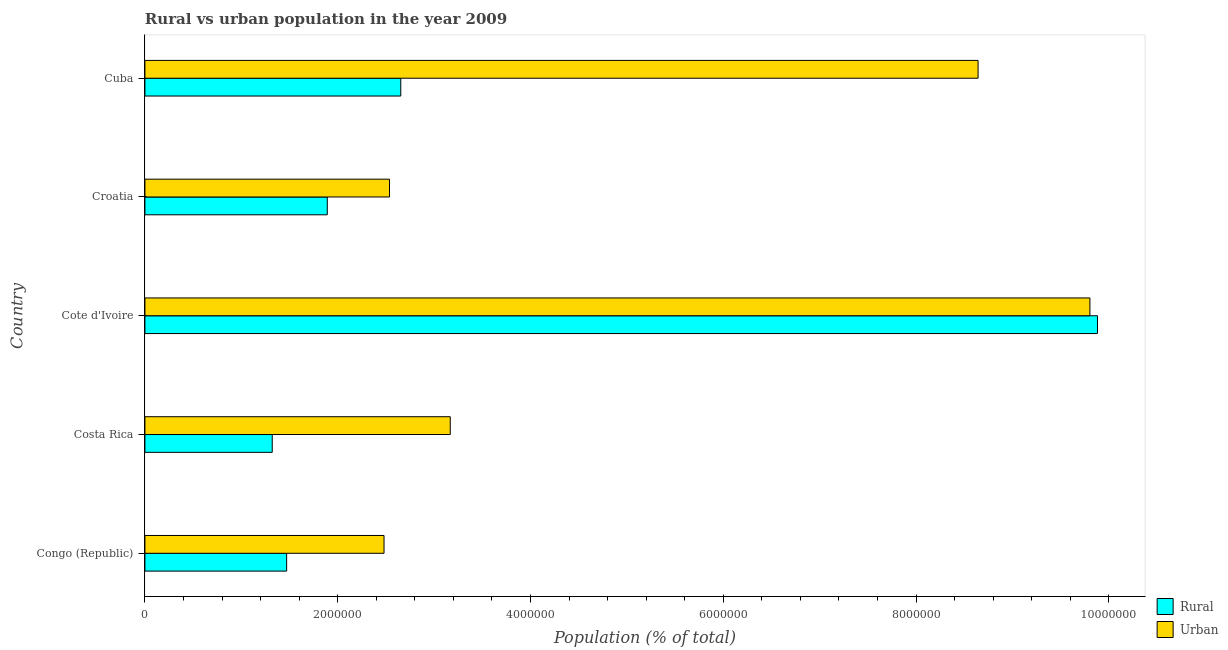How many groups of bars are there?
Offer a very short reply. 5. Are the number of bars per tick equal to the number of legend labels?
Keep it short and to the point. Yes. Are the number of bars on each tick of the Y-axis equal?
Provide a succinct answer. Yes. How many bars are there on the 5th tick from the bottom?
Keep it short and to the point. 2. What is the label of the 4th group of bars from the top?
Offer a terse response. Costa Rica. What is the rural population density in Cote d'Ivoire?
Provide a succinct answer. 9.88e+06. Across all countries, what is the maximum urban population density?
Offer a very short reply. 9.80e+06. Across all countries, what is the minimum rural population density?
Offer a terse response. 1.32e+06. In which country was the rural population density maximum?
Give a very brief answer. Cote d'Ivoire. In which country was the urban population density minimum?
Give a very brief answer. Congo (Republic). What is the total urban population density in the graph?
Your answer should be compact. 2.66e+07. What is the difference between the urban population density in Congo (Republic) and that in Cote d'Ivoire?
Your answer should be compact. -7.32e+06. What is the difference between the urban population density in Congo (Republic) and the rural population density in Cuba?
Offer a terse response. -1.74e+05. What is the average urban population density per country?
Provide a short and direct response. 5.33e+06. What is the difference between the rural population density and urban population density in Cote d'Ivoire?
Make the answer very short. 7.87e+04. In how many countries, is the urban population density greater than 1200000 %?
Offer a terse response. 5. What is the ratio of the urban population density in Costa Rica to that in Croatia?
Offer a very short reply. 1.25. Is the urban population density in Congo (Republic) less than that in Croatia?
Keep it short and to the point. Yes. What is the difference between the highest and the second highest urban population density?
Ensure brevity in your answer.  1.16e+06. What is the difference between the highest and the lowest urban population density?
Provide a succinct answer. 7.32e+06. What does the 2nd bar from the top in Cuba represents?
Your answer should be very brief. Rural. What does the 1st bar from the bottom in Cote d'Ivoire represents?
Provide a short and direct response. Rural. Are all the bars in the graph horizontal?
Offer a terse response. Yes. What is the difference between two consecutive major ticks on the X-axis?
Provide a short and direct response. 2.00e+06. Does the graph contain any zero values?
Provide a succinct answer. No. Does the graph contain grids?
Keep it short and to the point. No. Where does the legend appear in the graph?
Provide a short and direct response. Bottom right. How many legend labels are there?
Give a very brief answer. 2. How are the legend labels stacked?
Ensure brevity in your answer.  Vertical. What is the title of the graph?
Ensure brevity in your answer.  Rural vs urban population in the year 2009. What is the label or title of the X-axis?
Ensure brevity in your answer.  Population (% of total). What is the label or title of the Y-axis?
Your response must be concise. Country. What is the Population (% of total) of Rural in Congo (Republic)?
Give a very brief answer. 1.47e+06. What is the Population (% of total) in Urban in Congo (Republic)?
Your answer should be very brief. 2.48e+06. What is the Population (% of total) of Rural in Costa Rica?
Provide a succinct answer. 1.32e+06. What is the Population (% of total) in Urban in Costa Rica?
Your answer should be very brief. 3.17e+06. What is the Population (% of total) in Rural in Cote d'Ivoire?
Give a very brief answer. 9.88e+06. What is the Population (% of total) of Urban in Cote d'Ivoire?
Ensure brevity in your answer.  9.80e+06. What is the Population (% of total) in Rural in Croatia?
Provide a short and direct response. 1.89e+06. What is the Population (% of total) in Urban in Croatia?
Keep it short and to the point. 2.54e+06. What is the Population (% of total) in Rural in Cuba?
Your answer should be very brief. 2.65e+06. What is the Population (% of total) of Urban in Cuba?
Provide a succinct answer. 8.64e+06. Across all countries, what is the maximum Population (% of total) of Rural?
Your response must be concise. 9.88e+06. Across all countries, what is the maximum Population (% of total) of Urban?
Your answer should be very brief. 9.80e+06. Across all countries, what is the minimum Population (% of total) in Rural?
Provide a succinct answer. 1.32e+06. Across all countries, what is the minimum Population (% of total) in Urban?
Provide a short and direct response. 2.48e+06. What is the total Population (% of total) in Rural in the graph?
Make the answer very short. 1.72e+07. What is the total Population (% of total) of Urban in the graph?
Your answer should be very brief. 2.66e+07. What is the difference between the Population (% of total) of Rural in Congo (Republic) and that in Costa Rica?
Provide a succinct answer. 1.49e+05. What is the difference between the Population (% of total) in Urban in Congo (Republic) and that in Costa Rica?
Your answer should be compact. -6.87e+05. What is the difference between the Population (% of total) in Rural in Congo (Republic) and that in Cote d'Ivoire?
Your answer should be compact. -8.41e+06. What is the difference between the Population (% of total) of Urban in Congo (Republic) and that in Cote d'Ivoire?
Ensure brevity in your answer.  -7.32e+06. What is the difference between the Population (% of total) of Rural in Congo (Republic) and that in Croatia?
Offer a terse response. -4.22e+05. What is the difference between the Population (% of total) in Urban in Congo (Republic) and that in Croatia?
Ensure brevity in your answer.  -5.67e+04. What is the difference between the Population (% of total) of Rural in Congo (Republic) and that in Cuba?
Your answer should be compact. -1.18e+06. What is the difference between the Population (% of total) of Urban in Congo (Republic) and that in Cuba?
Provide a short and direct response. -6.16e+06. What is the difference between the Population (% of total) in Rural in Costa Rica and that in Cote d'Ivoire?
Provide a succinct answer. -8.56e+06. What is the difference between the Population (% of total) in Urban in Costa Rica and that in Cote d'Ivoire?
Your answer should be compact. -6.64e+06. What is the difference between the Population (% of total) of Rural in Costa Rica and that in Croatia?
Your response must be concise. -5.71e+05. What is the difference between the Population (% of total) in Urban in Costa Rica and that in Croatia?
Ensure brevity in your answer.  6.30e+05. What is the difference between the Population (% of total) of Rural in Costa Rica and that in Cuba?
Ensure brevity in your answer.  -1.33e+06. What is the difference between the Population (% of total) in Urban in Costa Rica and that in Cuba?
Your response must be concise. -5.48e+06. What is the difference between the Population (% of total) in Rural in Cote d'Ivoire and that in Croatia?
Keep it short and to the point. 7.99e+06. What is the difference between the Population (% of total) of Urban in Cote d'Ivoire and that in Croatia?
Offer a terse response. 7.27e+06. What is the difference between the Population (% of total) of Rural in Cote d'Ivoire and that in Cuba?
Your response must be concise. 7.23e+06. What is the difference between the Population (% of total) in Urban in Cote d'Ivoire and that in Cuba?
Your response must be concise. 1.16e+06. What is the difference between the Population (% of total) in Rural in Croatia and that in Cuba?
Your answer should be very brief. -7.63e+05. What is the difference between the Population (% of total) of Urban in Croatia and that in Cuba?
Your answer should be very brief. -6.11e+06. What is the difference between the Population (% of total) of Rural in Congo (Republic) and the Population (% of total) of Urban in Costa Rica?
Your answer should be compact. -1.70e+06. What is the difference between the Population (% of total) of Rural in Congo (Republic) and the Population (% of total) of Urban in Cote d'Ivoire?
Your answer should be compact. -8.33e+06. What is the difference between the Population (% of total) of Rural in Congo (Republic) and the Population (% of total) of Urban in Croatia?
Keep it short and to the point. -1.07e+06. What is the difference between the Population (% of total) of Rural in Congo (Republic) and the Population (% of total) of Urban in Cuba?
Your response must be concise. -7.17e+06. What is the difference between the Population (% of total) in Rural in Costa Rica and the Population (% of total) in Urban in Cote d'Ivoire?
Make the answer very short. -8.48e+06. What is the difference between the Population (% of total) of Rural in Costa Rica and the Population (% of total) of Urban in Croatia?
Your answer should be very brief. -1.22e+06. What is the difference between the Population (% of total) in Rural in Costa Rica and the Population (% of total) in Urban in Cuba?
Your response must be concise. -7.32e+06. What is the difference between the Population (% of total) in Rural in Cote d'Ivoire and the Population (% of total) in Urban in Croatia?
Give a very brief answer. 7.34e+06. What is the difference between the Population (% of total) in Rural in Cote d'Ivoire and the Population (% of total) in Urban in Cuba?
Offer a terse response. 1.24e+06. What is the difference between the Population (% of total) of Rural in Croatia and the Population (% of total) of Urban in Cuba?
Offer a terse response. -6.75e+06. What is the average Population (% of total) of Rural per country?
Offer a terse response. 3.44e+06. What is the average Population (% of total) in Urban per country?
Your response must be concise. 5.33e+06. What is the difference between the Population (% of total) in Rural and Population (% of total) in Urban in Congo (Republic)?
Your answer should be very brief. -1.01e+06. What is the difference between the Population (% of total) of Rural and Population (% of total) of Urban in Costa Rica?
Ensure brevity in your answer.  -1.85e+06. What is the difference between the Population (% of total) of Rural and Population (% of total) of Urban in Cote d'Ivoire?
Your answer should be compact. 7.87e+04. What is the difference between the Population (% of total) in Rural and Population (% of total) in Urban in Croatia?
Your answer should be very brief. -6.45e+05. What is the difference between the Population (% of total) in Rural and Population (% of total) in Urban in Cuba?
Offer a terse response. -5.99e+06. What is the ratio of the Population (% of total) in Rural in Congo (Republic) to that in Costa Rica?
Your response must be concise. 1.11. What is the ratio of the Population (% of total) in Urban in Congo (Republic) to that in Costa Rica?
Give a very brief answer. 0.78. What is the ratio of the Population (% of total) in Rural in Congo (Republic) to that in Cote d'Ivoire?
Offer a very short reply. 0.15. What is the ratio of the Population (% of total) in Urban in Congo (Republic) to that in Cote d'Ivoire?
Give a very brief answer. 0.25. What is the ratio of the Population (% of total) of Rural in Congo (Republic) to that in Croatia?
Make the answer very short. 0.78. What is the ratio of the Population (% of total) of Urban in Congo (Republic) to that in Croatia?
Your response must be concise. 0.98. What is the ratio of the Population (% of total) in Rural in Congo (Republic) to that in Cuba?
Offer a terse response. 0.55. What is the ratio of the Population (% of total) of Urban in Congo (Republic) to that in Cuba?
Your answer should be very brief. 0.29. What is the ratio of the Population (% of total) in Rural in Costa Rica to that in Cote d'Ivoire?
Your answer should be compact. 0.13. What is the ratio of the Population (% of total) in Urban in Costa Rica to that in Cote d'Ivoire?
Provide a short and direct response. 0.32. What is the ratio of the Population (% of total) of Rural in Costa Rica to that in Croatia?
Make the answer very short. 0.7. What is the ratio of the Population (% of total) in Urban in Costa Rica to that in Croatia?
Your answer should be compact. 1.25. What is the ratio of the Population (% of total) in Rural in Costa Rica to that in Cuba?
Your answer should be very brief. 0.5. What is the ratio of the Population (% of total) of Urban in Costa Rica to that in Cuba?
Give a very brief answer. 0.37. What is the ratio of the Population (% of total) of Rural in Cote d'Ivoire to that in Croatia?
Make the answer very short. 5.22. What is the ratio of the Population (% of total) of Urban in Cote d'Ivoire to that in Croatia?
Your answer should be very brief. 3.86. What is the ratio of the Population (% of total) in Rural in Cote d'Ivoire to that in Cuba?
Make the answer very short. 3.72. What is the ratio of the Population (% of total) in Urban in Cote d'Ivoire to that in Cuba?
Your response must be concise. 1.13. What is the ratio of the Population (% of total) of Rural in Croatia to that in Cuba?
Provide a succinct answer. 0.71. What is the ratio of the Population (% of total) of Urban in Croatia to that in Cuba?
Keep it short and to the point. 0.29. What is the difference between the highest and the second highest Population (% of total) in Rural?
Offer a very short reply. 7.23e+06. What is the difference between the highest and the second highest Population (% of total) in Urban?
Offer a very short reply. 1.16e+06. What is the difference between the highest and the lowest Population (% of total) of Rural?
Provide a short and direct response. 8.56e+06. What is the difference between the highest and the lowest Population (% of total) in Urban?
Offer a very short reply. 7.32e+06. 